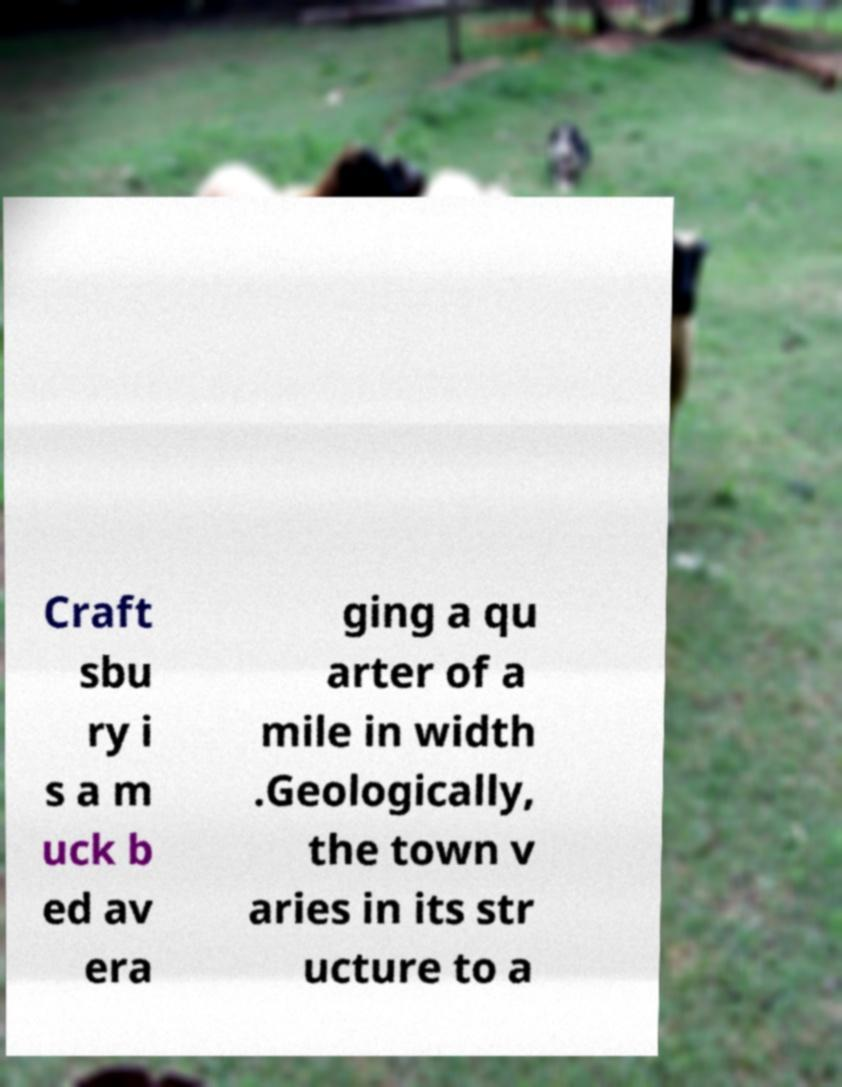For documentation purposes, I need the text within this image transcribed. Could you provide that? Craft sbu ry i s a m uck b ed av era ging a qu arter of a mile in width .Geologically, the town v aries in its str ucture to a 